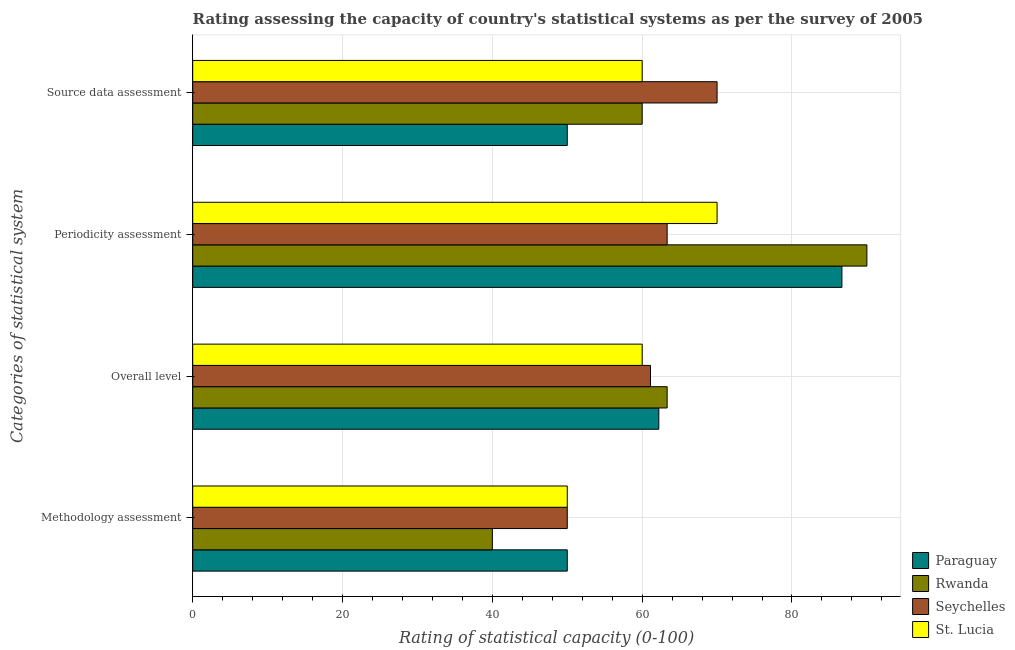Are the number of bars per tick equal to the number of legend labels?
Provide a succinct answer. Yes. Are the number of bars on each tick of the Y-axis equal?
Keep it short and to the point. Yes. How many bars are there on the 3rd tick from the bottom?
Your response must be concise. 4. What is the label of the 2nd group of bars from the top?
Provide a succinct answer. Periodicity assessment. Across all countries, what is the maximum methodology assessment rating?
Provide a succinct answer. 50. In which country was the source data assessment rating maximum?
Your answer should be compact. Seychelles. In which country was the overall level rating minimum?
Provide a succinct answer. St. Lucia. What is the total methodology assessment rating in the graph?
Your answer should be very brief. 190. What is the difference between the source data assessment rating in Seychelles and that in Paraguay?
Offer a very short reply. 20. What is the difference between the periodicity assessment rating in Paraguay and the methodology assessment rating in Seychelles?
Make the answer very short. 36.67. What is the average overall level rating per country?
Your response must be concise. 61.67. What is the difference between the source data assessment rating and methodology assessment rating in Paraguay?
Provide a succinct answer. 0. In how many countries, is the source data assessment rating greater than 32 ?
Provide a short and direct response. 4. What is the ratio of the source data assessment rating in Rwanda to that in St. Lucia?
Your answer should be very brief. 1. Is the source data assessment rating in St. Lucia less than that in Rwanda?
Your answer should be compact. No. What is the difference between the highest and the second highest periodicity assessment rating?
Your response must be concise. 3.33. What is the difference between the highest and the lowest overall level rating?
Your response must be concise. 3.33. Is the sum of the periodicity assessment rating in Seychelles and St. Lucia greater than the maximum methodology assessment rating across all countries?
Keep it short and to the point. Yes. Is it the case that in every country, the sum of the overall level rating and methodology assessment rating is greater than the sum of periodicity assessment rating and source data assessment rating?
Your answer should be compact. No. What does the 4th bar from the top in Source data assessment represents?
Make the answer very short. Paraguay. What does the 4th bar from the bottom in Overall level represents?
Keep it short and to the point. St. Lucia. How many bars are there?
Your answer should be compact. 16. How many countries are there in the graph?
Your answer should be very brief. 4. What is the difference between two consecutive major ticks on the X-axis?
Offer a very short reply. 20. Are the values on the major ticks of X-axis written in scientific E-notation?
Ensure brevity in your answer.  No. Does the graph contain any zero values?
Your response must be concise. No. Does the graph contain grids?
Your answer should be very brief. Yes. How are the legend labels stacked?
Provide a succinct answer. Vertical. What is the title of the graph?
Your response must be concise. Rating assessing the capacity of country's statistical systems as per the survey of 2005 . What is the label or title of the X-axis?
Offer a very short reply. Rating of statistical capacity (0-100). What is the label or title of the Y-axis?
Your answer should be very brief. Categories of statistical system. What is the Rating of statistical capacity (0-100) of Rwanda in Methodology assessment?
Provide a succinct answer. 40. What is the Rating of statistical capacity (0-100) of St. Lucia in Methodology assessment?
Offer a very short reply. 50. What is the Rating of statistical capacity (0-100) in Paraguay in Overall level?
Provide a short and direct response. 62.22. What is the Rating of statistical capacity (0-100) of Rwanda in Overall level?
Offer a very short reply. 63.33. What is the Rating of statistical capacity (0-100) in Seychelles in Overall level?
Provide a succinct answer. 61.11. What is the Rating of statistical capacity (0-100) in Paraguay in Periodicity assessment?
Your answer should be very brief. 86.67. What is the Rating of statistical capacity (0-100) in Rwanda in Periodicity assessment?
Keep it short and to the point. 90. What is the Rating of statistical capacity (0-100) of Seychelles in Periodicity assessment?
Provide a short and direct response. 63.33. What is the Rating of statistical capacity (0-100) of Paraguay in Source data assessment?
Offer a terse response. 50. What is the Rating of statistical capacity (0-100) of Rwanda in Source data assessment?
Offer a very short reply. 60. Across all Categories of statistical system, what is the maximum Rating of statistical capacity (0-100) of Paraguay?
Keep it short and to the point. 86.67. Across all Categories of statistical system, what is the maximum Rating of statistical capacity (0-100) of Rwanda?
Provide a short and direct response. 90. Across all Categories of statistical system, what is the maximum Rating of statistical capacity (0-100) of St. Lucia?
Offer a very short reply. 70. Across all Categories of statistical system, what is the minimum Rating of statistical capacity (0-100) in Rwanda?
Provide a succinct answer. 40. Across all Categories of statistical system, what is the minimum Rating of statistical capacity (0-100) in Seychelles?
Provide a succinct answer. 50. Across all Categories of statistical system, what is the minimum Rating of statistical capacity (0-100) of St. Lucia?
Offer a terse response. 50. What is the total Rating of statistical capacity (0-100) in Paraguay in the graph?
Your response must be concise. 248.89. What is the total Rating of statistical capacity (0-100) in Rwanda in the graph?
Ensure brevity in your answer.  253.33. What is the total Rating of statistical capacity (0-100) in Seychelles in the graph?
Keep it short and to the point. 244.44. What is the total Rating of statistical capacity (0-100) of St. Lucia in the graph?
Make the answer very short. 240. What is the difference between the Rating of statistical capacity (0-100) of Paraguay in Methodology assessment and that in Overall level?
Provide a short and direct response. -12.22. What is the difference between the Rating of statistical capacity (0-100) of Rwanda in Methodology assessment and that in Overall level?
Provide a short and direct response. -23.33. What is the difference between the Rating of statistical capacity (0-100) of Seychelles in Methodology assessment and that in Overall level?
Provide a short and direct response. -11.11. What is the difference between the Rating of statistical capacity (0-100) in St. Lucia in Methodology assessment and that in Overall level?
Provide a succinct answer. -10. What is the difference between the Rating of statistical capacity (0-100) in Paraguay in Methodology assessment and that in Periodicity assessment?
Your answer should be very brief. -36.67. What is the difference between the Rating of statistical capacity (0-100) of Rwanda in Methodology assessment and that in Periodicity assessment?
Your answer should be compact. -50. What is the difference between the Rating of statistical capacity (0-100) of Seychelles in Methodology assessment and that in Periodicity assessment?
Offer a terse response. -13.33. What is the difference between the Rating of statistical capacity (0-100) of St. Lucia in Methodology assessment and that in Periodicity assessment?
Offer a terse response. -20. What is the difference between the Rating of statistical capacity (0-100) in Paraguay in Overall level and that in Periodicity assessment?
Provide a short and direct response. -24.44. What is the difference between the Rating of statistical capacity (0-100) of Rwanda in Overall level and that in Periodicity assessment?
Keep it short and to the point. -26.67. What is the difference between the Rating of statistical capacity (0-100) in Seychelles in Overall level and that in Periodicity assessment?
Ensure brevity in your answer.  -2.22. What is the difference between the Rating of statistical capacity (0-100) of Paraguay in Overall level and that in Source data assessment?
Offer a very short reply. 12.22. What is the difference between the Rating of statistical capacity (0-100) in Rwanda in Overall level and that in Source data assessment?
Your answer should be compact. 3.33. What is the difference between the Rating of statistical capacity (0-100) in Seychelles in Overall level and that in Source data assessment?
Provide a short and direct response. -8.89. What is the difference between the Rating of statistical capacity (0-100) of St. Lucia in Overall level and that in Source data assessment?
Ensure brevity in your answer.  0. What is the difference between the Rating of statistical capacity (0-100) in Paraguay in Periodicity assessment and that in Source data assessment?
Ensure brevity in your answer.  36.67. What is the difference between the Rating of statistical capacity (0-100) of Seychelles in Periodicity assessment and that in Source data assessment?
Keep it short and to the point. -6.67. What is the difference between the Rating of statistical capacity (0-100) of St. Lucia in Periodicity assessment and that in Source data assessment?
Make the answer very short. 10. What is the difference between the Rating of statistical capacity (0-100) in Paraguay in Methodology assessment and the Rating of statistical capacity (0-100) in Rwanda in Overall level?
Offer a very short reply. -13.33. What is the difference between the Rating of statistical capacity (0-100) in Paraguay in Methodology assessment and the Rating of statistical capacity (0-100) in Seychelles in Overall level?
Ensure brevity in your answer.  -11.11. What is the difference between the Rating of statistical capacity (0-100) of Rwanda in Methodology assessment and the Rating of statistical capacity (0-100) of Seychelles in Overall level?
Your answer should be very brief. -21.11. What is the difference between the Rating of statistical capacity (0-100) in Paraguay in Methodology assessment and the Rating of statistical capacity (0-100) in Rwanda in Periodicity assessment?
Offer a terse response. -40. What is the difference between the Rating of statistical capacity (0-100) in Paraguay in Methodology assessment and the Rating of statistical capacity (0-100) in Seychelles in Periodicity assessment?
Your response must be concise. -13.33. What is the difference between the Rating of statistical capacity (0-100) in Paraguay in Methodology assessment and the Rating of statistical capacity (0-100) in St. Lucia in Periodicity assessment?
Keep it short and to the point. -20. What is the difference between the Rating of statistical capacity (0-100) in Rwanda in Methodology assessment and the Rating of statistical capacity (0-100) in Seychelles in Periodicity assessment?
Offer a very short reply. -23.33. What is the difference between the Rating of statistical capacity (0-100) in Rwanda in Methodology assessment and the Rating of statistical capacity (0-100) in St. Lucia in Periodicity assessment?
Keep it short and to the point. -30. What is the difference between the Rating of statistical capacity (0-100) of Seychelles in Methodology assessment and the Rating of statistical capacity (0-100) of St. Lucia in Periodicity assessment?
Your answer should be compact. -20. What is the difference between the Rating of statistical capacity (0-100) in Paraguay in Methodology assessment and the Rating of statistical capacity (0-100) in Seychelles in Source data assessment?
Your answer should be very brief. -20. What is the difference between the Rating of statistical capacity (0-100) of Paraguay in Methodology assessment and the Rating of statistical capacity (0-100) of St. Lucia in Source data assessment?
Provide a succinct answer. -10. What is the difference between the Rating of statistical capacity (0-100) of Rwanda in Methodology assessment and the Rating of statistical capacity (0-100) of Seychelles in Source data assessment?
Your response must be concise. -30. What is the difference between the Rating of statistical capacity (0-100) in Paraguay in Overall level and the Rating of statistical capacity (0-100) in Rwanda in Periodicity assessment?
Offer a very short reply. -27.78. What is the difference between the Rating of statistical capacity (0-100) of Paraguay in Overall level and the Rating of statistical capacity (0-100) of Seychelles in Periodicity assessment?
Your answer should be compact. -1.11. What is the difference between the Rating of statistical capacity (0-100) of Paraguay in Overall level and the Rating of statistical capacity (0-100) of St. Lucia in Periodicity assessment?
Provide a short and direct response. -7.78. What is the difference between the Rating of statistical capacity (0-100) in Rwanda in Overall level and the Rating of statistical capacity (0-100) in Seychelles in Periodicity assessment?
Offer a very short reply. 0. What is the difference between the Rating of statistical capacity (0-100) of Rwanda in Overall level and the Rating of statistical capacity (0-100) of St. Lucia in Periodicity assessment?
Give a very brief answer. -6.67. What is the difference between the Rating of statistical capacity (0-100) of Seychelles in Overall level and the Rating of statistical capacity (0-100) of St. Lucia in Periodicity assessment?
Your answer should be very brief. -8.89. What is the difference between the Rating of statistical capacity (0-100) of Paraguay in Overall level and the Rating of statistical capacity (0-100) of Rwanda in Source data assessment?
Your answer should be very brief. 2.22. What is the difference between the Rating of statistical capacity (0-100) in Paraguay in Overall level and the Rating of statistical capacity (0-100) in Seychelles in Source data assessment?
Ensure brevity in your answer.  -7.78. What is the difference between the Rating of statistical capacity (0-100) of Paraguay in Overall level and the Rating of statistical capacity (0-100) of St. Lucia in Source data assessment?
Your answer should be very brief. 2.22. What is the difference between the Rating of statistical capacity (0-100) in Rwanda in Overall level and the Rating of statistical capacity (0-100) in Seychelles in Source data assessment?
Your answer should be very brief. -6.67. What is the difference between the Rating of statistical capacity (0-100) of Rwanda in Overall level and the Rating of statistical capacity (0-100) of St. Lucia in Source data assessment?
Provide a succinct answer. 3.33. What is the difference between the Rating of statistical capacity (0-100) of Seychelles in Overall level and the Rating of statistical capacity (0-100) of St. Lucia in Source data assessment?
Your answer should be very brief. 1.11. What is the difference between the Rating of statistical capacity (0-100) of Paraguay in Periodicity assessment and the Rating of statistical capacity (0-100) of Rwanda in Source data assessment?
Provide a succinct answer. 26.67. What is the difference between the Rating of statistical capacity (0-100) in Paraguay in Periodicity assessment and the Rating of statistical capacity (0-100) in Seychelles in Source data assessment?
Provide a short and direct response. 16.67. What is the difference between the Rating of statistical capacity (0-100) of Paraguay in Periodicity assessment and the Rating of statistical capacity (0-100) of St. Lucia in Source data assessment?
Keep it short and to the point. 26.67. What is the difference between the Rating of statistical capacity (0-100) of Seychelles in Periodicity assessment and the Rating of statistical capacity (0-100) of St. Lucia in Source data assessment?
Provide a short and direct response. 3.33. What is the average Rating of statistical capacity (0-100) in Paraguay per Categories of statistical system?
Offer a very short reply. 62.22. What is the average Rating of statistical capacity (0-100) in Rwanda per Categories of statistical system?
Your answer should be very brief. 63.33. What is the average Rating of statistical capacity (0-100) of Seychelles per Categories of statistical system?
Provide a short and direct response. 61.11. What is the difference between the Rating of statistical capacity (0-100) of Seychelles and Rating of statistical capacity (0-100) of St. Lucia in Methodology assessment?
Give a very brief answer. 0. What is the difference between the Rating of statistical capacity (0-100) of Paraguay and Rating of statistical capacity (0-100) of Rwanda in Overall level?
Provide a succinct answer. -1.11. What is the difference between the Rating of statistical capacity (0-100) in Paraguay and Rating of statistical capacity (0-100) in St. Lucia in Overall level?
Your response must be concise. 2.22. What is the difference between the Rating of statistical capacity (0-100) in Rwanda and Rating of statistical capacity (0-100) in Seychelles in Overall level?
Offer a terse response. 2.22. What is the difference between the Rating of statistical capacity (0-100) in Seychelles and Rating of statistical capacity (0-100) in St. Lucia in Overall level?
Offer a terse response. 1.11. What is the difference between the Rating of statistical capacity (0-100) of Paraguay and Rating of statistical capacity (0-100) of Seychelles in Periodicity assessment?
Make the answer very short. 23.33. What is the difference between the Rating of statistical capacity (0-100) of Paraguay and Rating of statistical capacity (0-100) of St. Lucia in Periodicity assessment?
Your answer should be very brief. 16.67. What is the difference between the Rating of statistical capacity (0-100) of Rwanda and Rating of statistical capacity (0-100) of Seychelles in Periodicity assessment?
Ensure brevity in your answer.  26.67. What is the difference between the Rating of statistical capacity (0-100) of Rwanda and Rating of statistical capacity (0-100) of St. Lucia in Periodicity assessment?
Ensure brevity in your answer.  20. What is the difference between the Rating of statistical capacity (0-100) of Seychelles and Rating of statistical capacity (0-100) of St. Lucia in Periodicity assessment?
Offer a terse response. -6.67. What is the difference between the Rating of statistical capacity (0-100) of Paraguay and Rating of statistical capacity (0-100) of St. Lucia in Source data assessment?
Your answer should be compact. -10. What is the difference between the Rating of statistical capacity (0-100) of Rwanda and Rating of statistical capacity (0-100) of Seychelles in Source data assessment?
Your answer should be very brief. -10. What is the difference between the Rating of statistical capacity (0-100) in Rwanda and Rating of statistical capacity (0-100) in St. Lucia in Source data assessment?
Offer a terse response. 0. What is the difference between the Rating of statistical capacity (0-100) of Seychelles and Rating of statistical capacity (0-100) of St. Lucia in Source data assessment?
Offer a very short reply. 10. What is the ratio of the Rating of statistical capacity (0-100) of Paraguay in Methodology assessment to that in Overall level?
Offer a very short reply. 0.8. What is the ratio of the Rating of statistical capacity (0-100) in Rwanda in Methodology assessment to that in Overall level?
Ensure brevity in your answer.  0.63. What is the ratio of the Rating of statistical capacity (0-100) of Seychelles in Methodology assessment to that in Overall level?
Ensure brevity in your answer.  0.82. What is the ratio of the Rating of statistical capacity (0-100) of St. Lucia in Methodology assessment to that in Overall level?
Make the answer very short. 0.83. What is the ratio of the Rating of statistical capacity (0-100) in Paraguay in Methodology assessment to that in Periodicity assessment?
Provide a short and direct response. 0.58. What is the ratio of the Rating of statistical capacity (0-100) in Rwanda in Methodology assessment to that in Periodicity assessment?
Keep it short and to the point. 0.44. What is the ratio of the Rating of statistical capacity (0-100) of Seychelles in Methodology assessment to that in Periodicity assessment?
Offer a very short reply. 0.79. What is the ratio of the Rating of statistical capacity (0-100) in St. Lucia in Methodology assessment to that in Periodicity assessment?
Your answer should be very brief. 0.71. What is the ratio of the Rating of statistical capacity (0-100) in Paraguay in Methodology assessment to that in Source data assessment?
Your answer should be very brief. 1. What is the ratio of the Rating of statistical capacity (0-100) in Rwanda in Methodology assessment to that in Source data assessment?
Your answer should be very brief. 0.67. What is the ratio of the Rating of statistical capacity (0-100) of Seychelles in Methodology assessment to that in Source data assessment?
Offer a terse response. 0.71. What is the ratio of the Rating of statistical capacity (0-100) of St. Lucia in Methodology assessment to that in Source data assessment?
Provide a short and direct response. 0.83. What is the ratio of the Rating of statistical capacity (0-100) of Paraguay in Overall level to that in Periodicity assessment?
Provide a short and direct response. 0.72. What is the ratio of the Rating of statistical capacity (0-100) in Rwanda in Overall level to that in Periodicity assessment?
Give a very brief answer. 0.7. What is the ratio of the Rating of statistical capacity (0-100) in Seychelles in Overall level to that in Periodicity assessment?
Your answer should be very brief. 0.96. What is the ratio of the Rating of statistical capacity (0-100) in Paraguay in Overall level to that in Source data assessment?
Keep it short and to the point. 1.24. What is the ratio of the Rating of statistical capacity (0-100) in Rwanda in Overall level to that in Source data assessment?
Keep it short and to the point. 1.06. What is the ratio of the Rating of statistical capacity (0-100) in Seychelles in Overall level to that in Source data assessment?
Offer a terse response. 0.87. What is the ratio of the Rating of statistical capacity (0-100) in Paraguay in Periodicity assessment to that in Source data assessment?
Your answer should be compact. 1.73. What is the ratio of the Rating of statistical capacity (0-100) of Rwanda in Periodicity assessment to that in Source data assessment?
Provide a short and direct response. 1.5. What is the ratio of the Rating of statistical capacity (0-100) of Seychelles in Periodicity assessment to that in Source data assessment?
Offer a terse response. 0.9. What is the ratio of the Rating of statistical capacity (0-100) of St. Lucia in Periodicity assessment to that in Source data assessment?
Your response must be concise. 1.17. What is the difference between the highest and the second highest Rating of statistical capacity (0-100) in Paraguay?
Your answer should be very brief. 24.44. What is the difference between the highest and the second highest Rating of statistical capacity (0-100) of Rwanda?
Make the answer very short. 26.67. What is the difference between the highest and the second highest Rating of statistical capacity (0-100) of St. Lucia?
Offer a terse response. 10. What is the difference between the highest and the lowest Rating of statistical capacity (0-100) in Paraguay?
Provide a succinct answer. 36.67. 